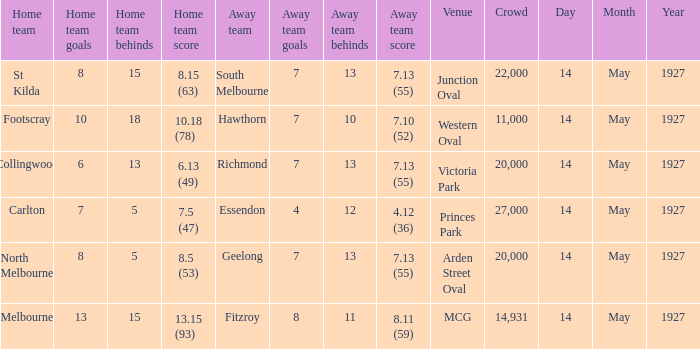Which offsite team had a score of Essendon. 